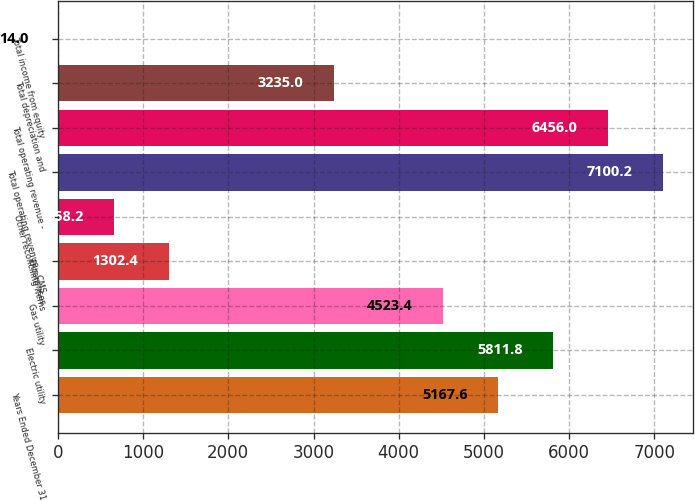Convert chart. <chart><loc_0><loc_0><loc_500><loc_500><bar_chart><fcel>Years Ended December 31<fcel>Electric utility<fcel>Gas utility<fcel>Enterprises<fcel>Other reconciling items<fcel>Total operating revenue - CMS<fcel>Total operating revenue -<fcel>Total depreciation and<fcel>Total income from equity<nl><fcel>5167.6<fcel>5811.8<fcel>4523.4<fcel>1302.4<fcel>658.2<fcel>7100.2<fcel>6456<fcel>3235<fcel>14<nl></chart> 